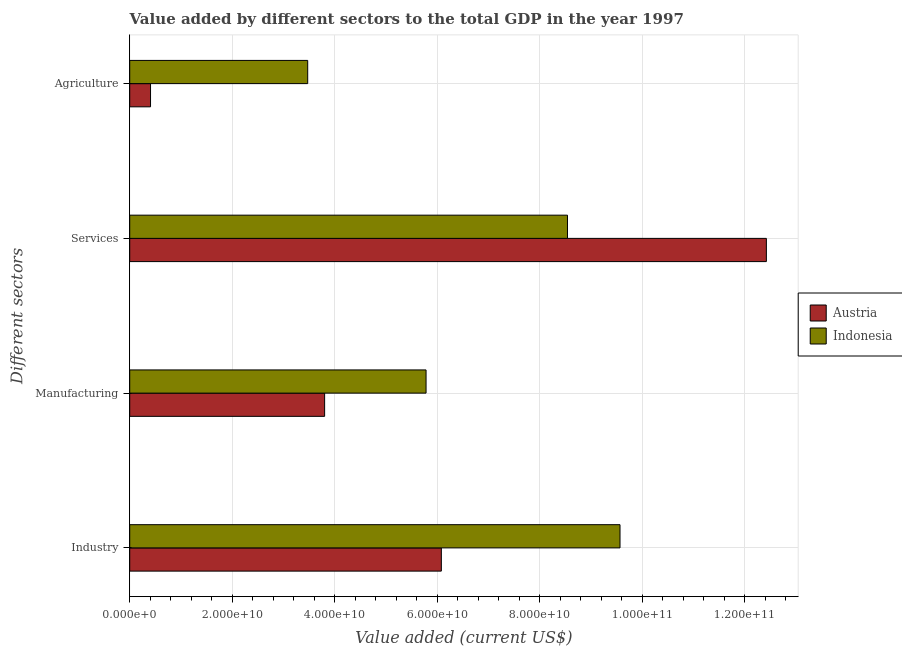How many different coloured bars are there?
Keep it short and to the point. 2. How many groups of bars are there?
Keep it short and to the point. 4. How many bars are there on the 1st tick from the bottom?
Your answer should be very brief. 2. What is the label of the 3rd group of bars from the top?
Keep it short and to the point. Manufacturing. What is the value added by industrial sector in Indonesia?
Offer a very short reply. 9.56e+1. Across all countries, what is the maximum value added by industrial sector?
Your response must be concise. 9.56e+1. Across all countries, what is the minimum value added by services sector?
Make the answer very short. 8.54e+1. In which country was the value added by manufacturing sector minimum?
Provide a succinct answer. Austria. What is the total value added by agricultural sector in the graph?
Make the answer very short. 3.88e+1. What is the difference between the value added by manufacturing sector in Indonesia and that in Austria?
Provide a short and direct response. 1.98e+1. What is the difference between the value added by manufacturing sector in Indonesia and the value added by services sector in Austria?
Provide a succinct answer. -6.64e+1. What is the average value added by agricultural sector per country?
Ensure brevity in your answer.  1.94e+1. What is the difference between the value added by agricultural sector and value added by services sector in Indonesia?
Make the answer very short. -5.07e+1. What is the ratio of the value added by industrial sector in Indonesia to that in Austria?
Give a very brief answer. 1.57. Is the value added by industrial sector in Indonesia less than that in Austria?
Your answer should be compact. No. What is the difference between the highest and the second highest value added by services sector?
Your answer should be very brief. 3.88e+1. What is the difference between the highest and the lowest value added by industrial sector?
Make the answer very short. 3.49e+1. What does the 1st bar from the top in Agriculture represents?
Keep it short and to the point. Indonesia. What does the 2nd bar from the bottom in Services represents?
Ensure brevity in your answer.  Indonesia. Is it the case that in every country, the sum of the value added by industrial sector and value added by manufacturing sector is greater than the value added by services sector?
Offer a very short reply. No. Are all the bars in the graph horizontal?
Your answer should be compact. Yes. How many countries are there in the graph?
Give a very brief answer. 2. Where does the legend appear in the graph?
Offer a terse response. Center right. How many legend labels are there?
Give a very brief answer. 2. How are the legend labels stacked?
Offer a terse response. Vertical. What is the title of the graph?
Make the answer very short. Value added by different sectors to the total GDP in the year 1997. What is the label or title of the X-axis?
Provide a short and direct response. Value added (current US$). What is the label or title of the Y-axis?
Make the answer very short. Different sectors. What is the Value added (current US$) in Austria in Industry?
Provide a short and direct response. 6.08e+1. What is the Value added (current US$) in Indonesia in Industry?
Offer a terse response. 9.56e+1. What is the Value added (current US$) in Austria in Manufacturing?
Make the answer very short. 3.80e+1. What is the Value added (current US$) of Indonesia in Manufacturing?
Provide a succinct answer. 5.78e+1. What is the Value added (current US$) of Austria in Services?
Provide a succinct answer. 1.24e+11. What is the Value added (current US$) of Indonesia in Services?
Make the answer very short. 8.54e+1. What is the Value added (current US$) of Austria in Agriculture?
Give a very brief answer. 4.06e+09. What is the Value added (current US$) in Indonesia in Agriculture?
Offer a terse response. 3.47e+1. Across all Different sectors, what is the maximum Value added (current US$) in Austria?
Your answer should be very brief. 1.24e+11. Across all Different sectors, what is the maximum Value added (current US$) in Indonesia?
Provide a short and direct response. 9.56e+1. Across all Different sectors, what is the minimum Value added (current US$) in Austria?
Your response must be concise. 4.06e+09. Across all Different sectors, what is the minimum Value added (current US$) in Indonesia?
Ensure brevity in your answer.  3.47e+1. What is the total Value added (current US$) in Austria in the graph?
Keep it short and to the point. 2.27e+11. What is the total Value added (current US$) of Indonesia in the graph?
Provide a succinct answer. 2.74e+11. What is the difference between the Value added (current US$) in Austria in Industry and that in Manufacturing?
Offer a terse response. 2.28e+1. What is the difference between the Value added (current US$) of Indonesia in Industry and that in Manufacturing?
Give a very brief answer. 3.78e+1. What is the difference between the Value added (current US$) in Austria in Industry and that in Services?
Give a very brief answer. -6.34e+1. What is the difference between the Value added (current US$) of Indonesia in Industry and that in Services?
Provide a succinct answer. 1.02e+1. What is the difference between the Value added (current US$) in Austria in Industry and that in Agriculture?
Your answer should be very brief. 5.67e+1. What is the difference between the Value added (current US$) in Indonesia in Industry and that in Agriculture?
Offer a terse response. 6.09e+1. What is the difference between the Value added (current US$) in Austria in Manufacturing and that in Services?
Your answer should be very brief. -8.62e+1. What is the difference between the Value added (current US$) of Indonesia in Manufacturing and that in Services?
Offer a terse response. -2.76e+1. What is the difference between the Value added (current US$) of Austria in Manufacturing and that in Agriculture?
Give a very brief answer. 3.40e+1. What is the difference between the Value added (current US$) of Indonesia in Manufacturing and that in Agriculture?
Your answer should be compact. 2.31e+1. What is the difference between the Value added (current US$) in Austria in Services and that in Agriculture?
Make the answer very short. 1.20e+11. What is the difference between the Value added (current US$) of Indonesia in Services and that in Agriculture?
Make the answer very short. 5.07e+1. What is the difference between the Value added (current US$) in Austria in Industry and the Value added (current US$) in Indonesia in Manufacturing?
Ensure brevity in your answer.  2.98e+09. What is the difference between the Value added (current US$) of Austria in Industry and the Value added (current US$) of Indonesia in Services?
Ensure brevity in your answer.  -2.46e+1. What is the difference between the Value added (current US$) in Austria in Industry and the Value added (current US$) in Indonesia in Agriculture?
Provide a short and direct response. 2.61e+1. What is the difference between the Value added (current US$) in Austria in Manufacturing and the Value added (current US$) in Indonesia in Services?
Provide a succinct answer. -4.74e+1. What is the difference between the Value added (current US$) in Austria in Manufacturing and the Value added (current US$) in Indonesia in Agriculture?
Your response must be concise. 3.30e+09. What is the difference between the Value added (current US$) of Austria in Services and the Value added (current US$) of Indonesia in Agriculture?
Make the answer very short. 8.95e+1. What is the average Value added (current US$) of Austria per Different sectors?
Your answer should be compact. 5.68e+1. What is the average Value added (current US$) of Indonesia per Different sectors?
Give a very brief answer. 6.84e+1. What is the difference between the Value added (current US$) of Austria and Value added (current US$) of Indonesia in Industry?
Offer a terse response. -3.49e+1. What is the difference between the Value added (current US$) of Austria and Value added (current US$) of Indonesia in Manufacturing?
Make the answer very short. -1.98e+1. What is the difference between the Value added (current US$) of Austria and Value added (current US$) of Indonesia in Services?
Your answer should be very brief. 3.88e+1. What is the difference between the Value added (current US$) of Austria and Value added (current US$) of Indonesia in Agriculture?
Your response must be concise. -3.07e+1. What is the ratio of the Value added (current US$) in Austria in Industry to that in Manufacturing?
Keep it short and to the point. 1.6. What is the ratio of the Value added (current US$) of Indonesia in Industry to that in Manufacturing?
Your response must be concise. 1.65. What is the ratio of the Value added (current US$) of Austria in Industry to that in Services?
Your answer should be very brief. 0.49. What is the ratio of the Value added (current US$) in Indonesia in Industry to that in Services?
Offer a very short reply. 1.12. What is the ratio of the Value added (current US$) in Austria in Industry to that in Agriculture?
Give a very brief answer. 14.97. What is the ratio of the Value added (current US$) of Indonesia in Industry to that in Agriculture?
Keep it short and to the point. 2.75. What is the ratio of the Value added (current US$) of Austria in Manufacturing to that in Services?
Your response must be concise. 0.31. What is the ratio of the Value added (current US$) of Indonesia in Manufacturing to that in Services?
Your answer should be compact. 0.68. What is the ratio of the Value added (current US$) in Austria in Manufacturing to that in Agriculture?
Your answer should be compact. 9.36. What is the ratio of the Value added (current US$) of Indonesia in Manufacturing to that in Agriculture?
Offer a very short reply. 1.67. What is the ratio of the Value added (current US$) of Austria in Services to that in Agriculture?
Your answer should be compact. 30.59. What is the ratio of the Value added (current US$) in Indonesia in Services to that in Agriculture?
Make the answer very short. 2.46. What is the difference between the highest and the second highest Value added (current US$) of Austria?
Provide a succinct answer. 6.34e+1. What is the difference between the highest and the second highest Value added (current US$) in Indonesia?
Make the answer very short. 1.02e+1. What is the difference between the highest and the lowest Value added (current US$) of Austria?
Ensure brevity in your answer.  1.20e+11. What is the difference between the highest and the lowest Value added (current US$) in Indonesia?
Offer a terse response. 6.09e+1. 